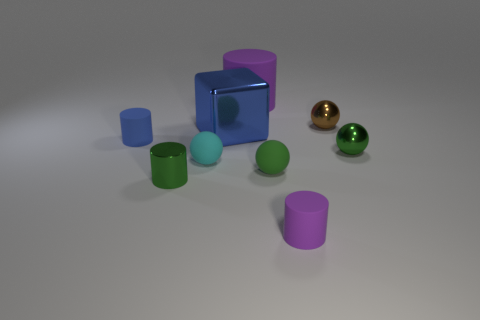Subtract 2 cylinders. How many cylinders are left? 2 Subtract all brown cylinders. Subtract all brown blocks. How many cylinders are left? 4 Add 1 large yellow shiny spheres. How many objects exist? 10 Subtract all cylinders. How many objects are left? 5 Subtract all small red metal objects. Subtract all tiny purple rubber cylinders. How many objects are left? 8 Add 1 small green balls. How many small green balls are left? 3 Add 4 brown spheres. How many brown spheres exist? 5 Subtract 0 gray cylinders. How many objects are left? 9 